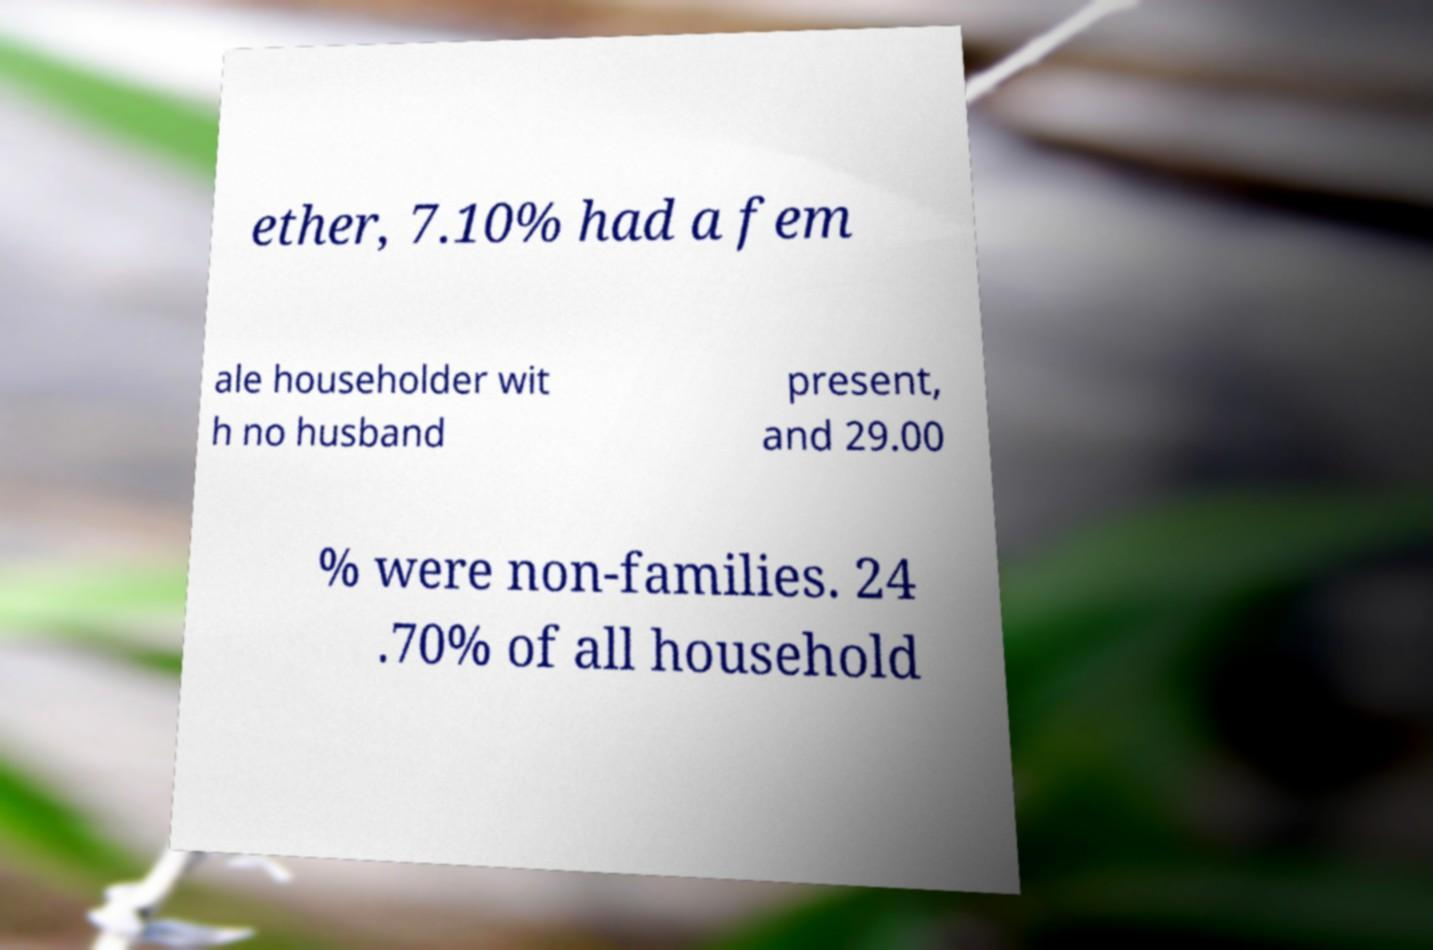Could you assist in decoding the text presented in this image and type it out clearly? ether, 7.10% had a fem ale householder wit h no husband present, and 29.00 % were non-families. 24 .70% of all household 